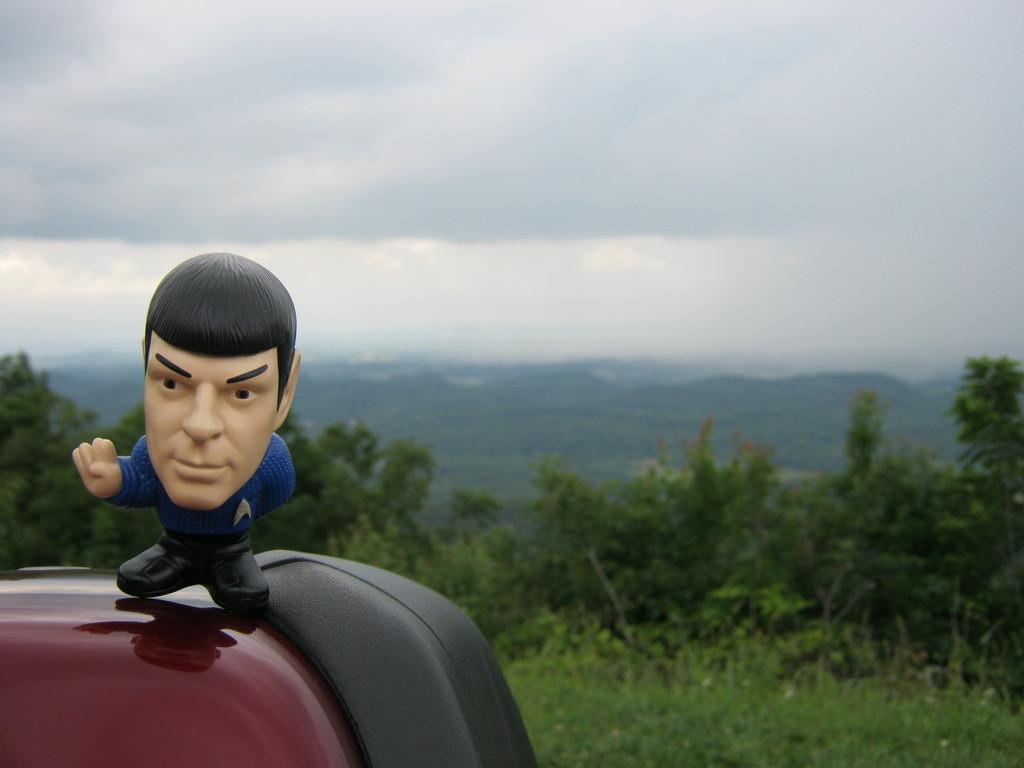What can be seen in the image that is not a natural element? There is a toy in the image. Where is the toy located? The toy is on an object. What type of vegetation is present in the image? There are plants and trees in the image. What can be seen in the distance in the image? There are hills visible in the background of the image. What is visible above the hills in the image? The sky is visible in the background of the image. What type of dock can be seen in the image? There is no dock present in the image. What grade of material is used to construct the trees in the image? The trees in the image are natural, and their construction does not involve any graded materials. 